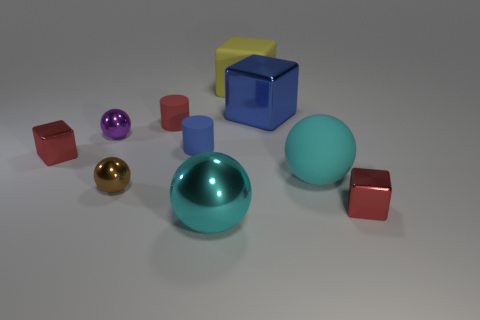What is the shape of the red object that is both in front of the small purple sphere and on the left side of the large cyan rubber sphere?
Provide a succinct answer. Cube. What size is the red block that is on the left side of the small shiny object that is on the right side of the large rubber cube?
Keep it short and to the point. Small. How many other objects are the same color as the big shiny block?
Give a very brief answer. 1. What is the material of the small purple thing?
Give a very brief answer. Metal. Is there a large yellow block?
Your answer should be compact. Yes. Are there the same number of blocks that are in front of the purple metallic ball and cylinders?
Keep it short and to the point. Yes. What number of big objects are either blue things or metallic balls?
Make the answer very short. 2. There is a big metal thing that is the same color as the matte ball; what is its shape?
Offer a very short reply. Sphere. Do the blue thing on the right side of the yellow block and the small brown thing have the same material?
Keep it short and to the point. Yes. The ball that is to the right of the blue block that is on the left side of the cyan matte thing is made of what material?
Provide a short and direct response. Rubber. 